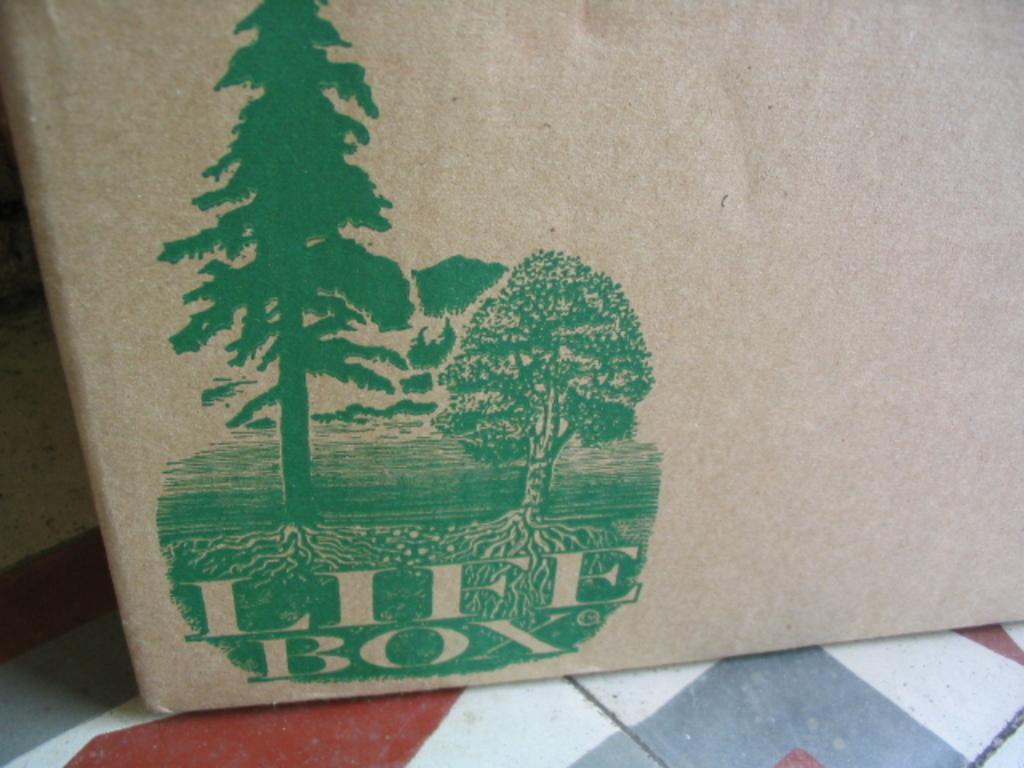<image>
Describe the image concisely. a picture of two trees and the words life box 